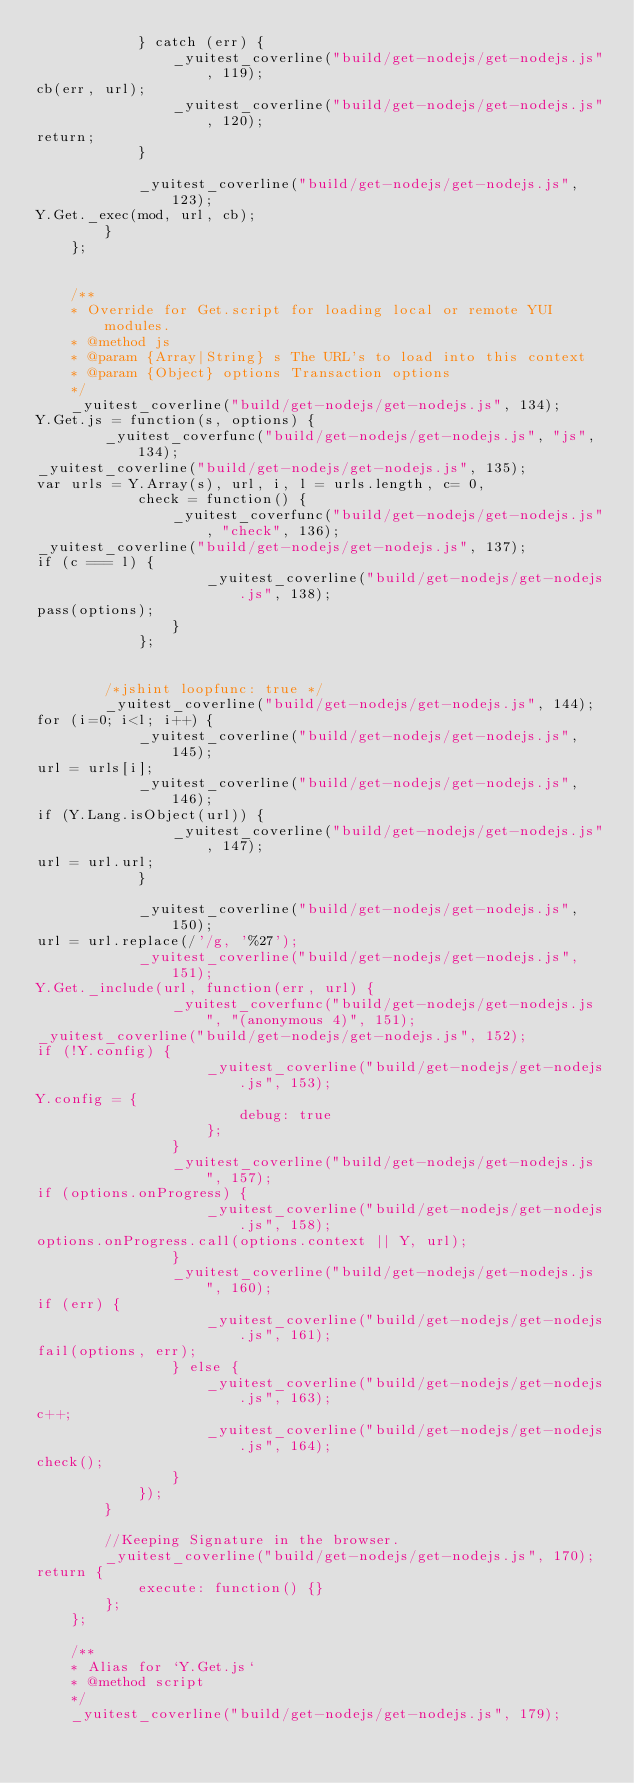<code> <loc_0><loc_0><loc_500><loc_500><_JavaScript_>            } catch (err) {
                _yuitest_coverline("build/get-nodejs/get-nodejs.js", 119);
cb(err, url);
                _yuitest_coverline("build/get-nodejs/get-nodejs.js", 120);
return;
            }

            _yuitest_coverline("build/get-nodejs/get-nodejs.js", 123);
Y.Get._exec(mod, url, cb);
        }
    };


    /**
    * Override for Get.script for loading local or remote YUI modules.
    * @method js
    * @param {Array|String} s The URL's to load into this context
    * @param {Object} options Transaction options
    */
    _yuitest_coverline("build/get-nodejs/get-nodejs.js", 134);
Y.Get.js = function(s, options) {
        _yuitest_coverfunc("build/get-nodejs/get-nodejs.js", "js", 134);
_yuitest_coverline("build/get-nodejs/get-nodejs.js", 135);
var urls = Y.Array(s), url, i, l = urls.length, c= 0,
            check = function() {
                _yuitest_coverfunc("build/get-nodejs/get-nodejs.js", "check", 136);
_yuitest_coverline("build/get-nodejs/get-nodejs.js", 137);
if (c === l) {
                    _yuitest_coverline("build/get-nodejs/get-nodejs.js", 138);
pass(options);
                }
            };


        /*jshint loopfunc: true */
        _yuitest_coverline("build/get-nodejs/get-nodejs.js", 144);
for (i=0; i<l; i++) {
            _yuitest_coverline("build/get-nodejs/get-nodejs.js", 145);
url = urls[i];
            _yuitest_coverline("build/get-nodejs/get-nodejs.js", 146);
if (Y.Lang.isObject(url)) {
                _yuitest_coverline("build/get-nodejs/get-nodejs.js", 147);
url = url.url;
            }

            _yuitest_coverline("build/get-nodejs/get-nodejs.js", 150);
url = url.replace(/'/g, '%27');
            _yuitest_coverline("build/get-nodejs/get-nodejs.js", 151);
Y.Get._include(url, function(err, url) {
                _yuitest_coverfunc("build/get-nodejs/get-nodejs.js", "(anonymous 4)", 151);
_yuitest_coverline("build/get-nodejs/get-nodejs.js", 152);
if (!Y.config) {
                    _yuitest_coverline("build/get-nodejs/get-nodejs.js", 153);
Y.config = {
                        debug: true
                    };
                }
                _yuitest_coverline("build/get-nodejs/get-nodejs.js", 157);
if (options.onProgress) {
                    _yuitest_coverline("build/get-nodejs/get-nodejs.js", 158);
options.onProgress.call(options.context || Y, url);
                }
                _yuitest_coverline("build/get-nodejs/get-nodejs.js", 160);
if (err) {
                    _yuitest_coverline("build/get-nodejs/get-nodejs.js", 161);
fail(options, err);
                } else {
                    _yuitest_coverline("build/get-nodejs/get-nodejs.js", 163);
c++;
                    _yuitest_coverline("build/get-nodejs/get-nodejs.js", 164);
check();
                }
            });
        }
        
        //Keeping Signature in the browser.
        _yuitest_coverline("build/get-nodejs/get-nodejs.js", 170);
return {
            execute: function() {}
        };
    };

    /**
    * Alias for `Y.Get.js`
    * @method script
    */
    _yuitest_coverline("build/get-nodejs/get-nodejs.js", 179);</code> 